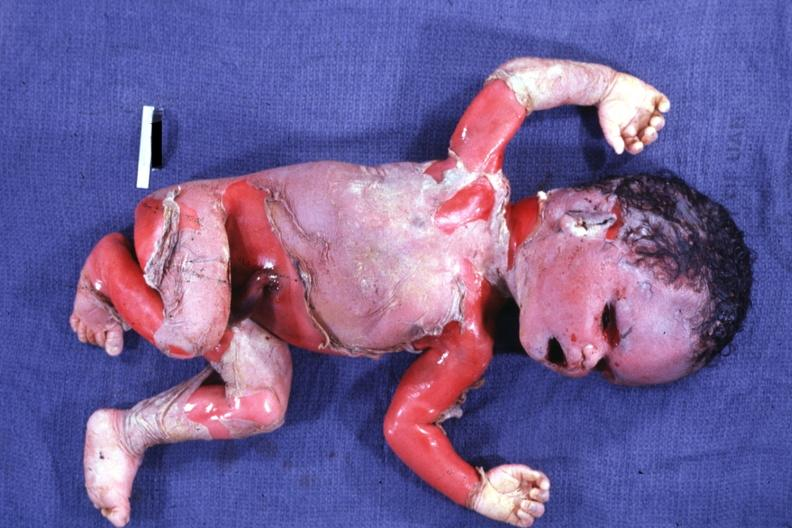what does this image show?
Answer the question using a single word or phrase. Severe maceration 